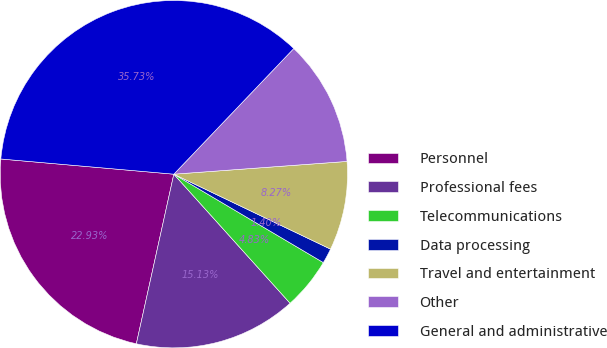Convert chart to OTSL. <chart><loc_0><loc_0><loc_500><loc_500><pie_chart><fcel>Personnel<fcel>Professional fees<fcel>Telecommunications<fcel>Data processing<fcel>Travel and entertainment<fcel>Other<fcel>General and administrative<nl><fcel>22.93%<fcel>15.13%<fcel>4.83%<fcel>1.4%<fcel>8.27%<fcel>11.7%<fcel>35.73%<nl></chart> 